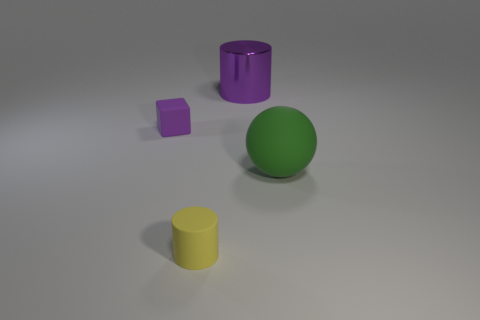Add 4 large matte spheres. How many objects exist? 8 Subtract all cubes. How many objects are left? 3 Subtract 0 purple balls. How many objects are left? 4 Subtract all green objects. Subtract all small cyan metallic balls. How many objects are left? 3 Add 3 matte cylinders. How many matte cylinders are left? 4 Add 2 small brown rubber objects. How many small brown rubber objects exist? 2 